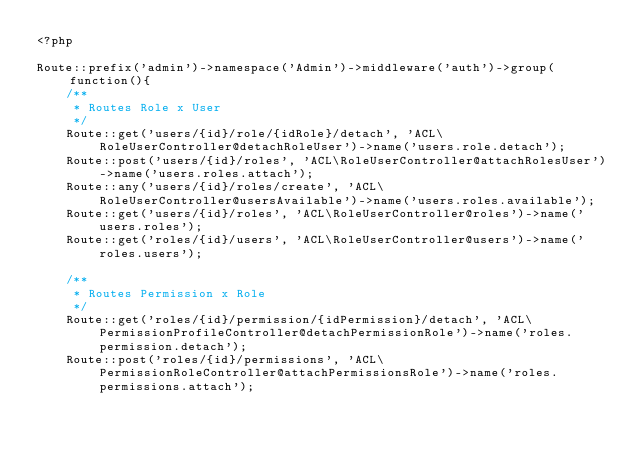Convert code to text. <code><loc_0><loc_0><loc_500><loc_500><_PHP_><?php

Route::prefix('admin')->namespace('Admin')->middleware('auth')->group(function(){
    /**
     * Routes Role x User
     */
    Route::get('users/{id}/role/{idRole}/detach', 'ACL\RoleUserController@detachRoleUser')->name('users.role.detach');
    Route::post('users/{id}/roles', 'ACL\RoleUserController@attachRolesUser')->name('users.roles.attach');
    Route::any('users/{id}/roles/create', 'ACL\RoleUserController@usersAvailable')->name('users.roles.available');
    Route::get('users/{id}/roles', 'ACL\RoleUserController@roles')->name('users.roles');
    Route::get('roles/{id}/users', 'ACL\RoleUserController@users')->name('roles.users');

    /**
     * Routes Permission x Role
     */
    Route::get('roles/{id}/permission/{idPermission}/detach', 'ACL\PermissionProfileController@detachPermissionRole')->name('roles.permission.detach');
    Route::post('roles/{id}/permissions', 'ACL\PermissionRoleController@attachPermissionsRole')->name('roles.permissions.attach');</code> 